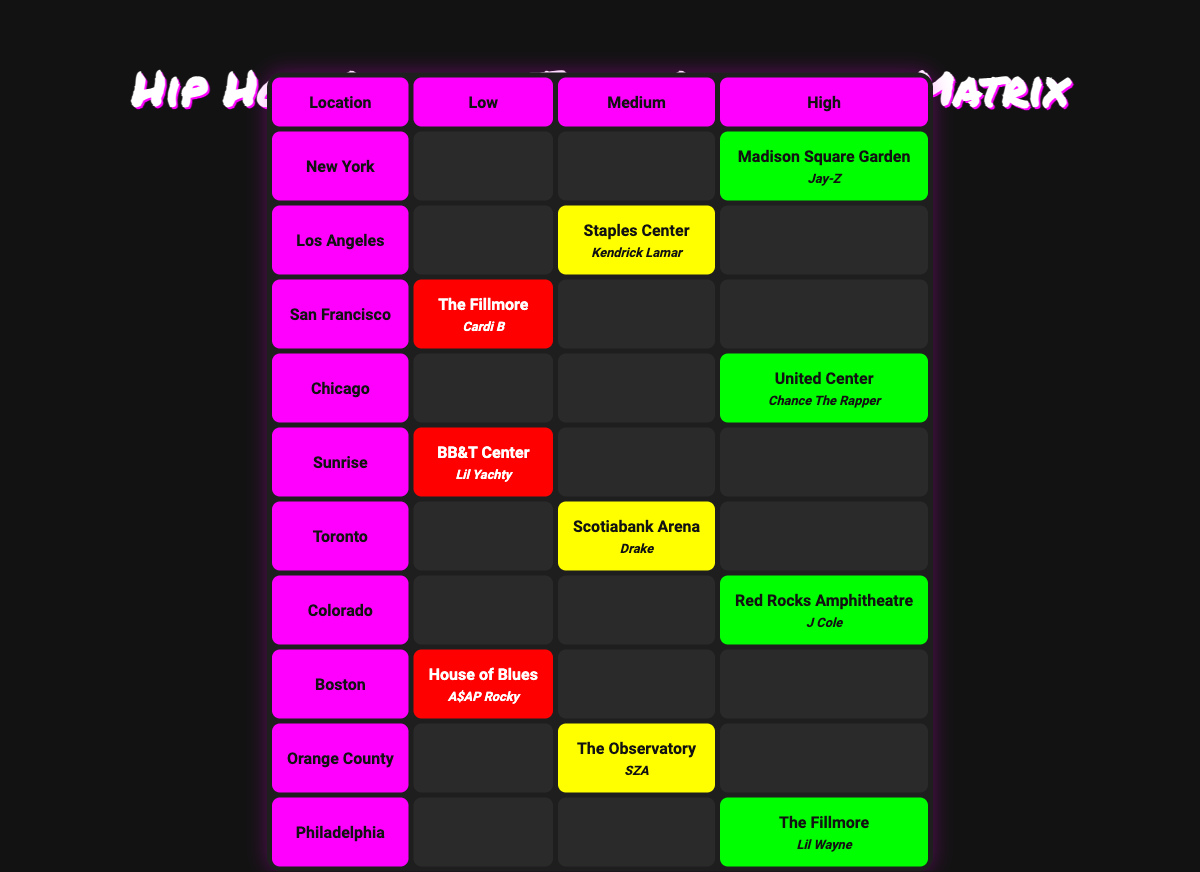What concert location had the highest ticket sales? According to the table, Madison Square Garden in New York shows a high ticket sale, identified in the "High" column. To verify, I check each city and find that "High" ticket sales apply to both Madison Square Garden and the United Center in Chicago, but Madison Square Garden is the first listed.
Answer: Madison Square Garden, New York Did any artist achieve low ticket sales in a major city? The table indicates that The Fillmore in San Francisco had low ticket sales. San Francisco is a major city, hence the answer is verified from the cell's data.
Answer: Yes How many locations had medium ticket sales? The matrix shows three locations with medium ticket sales: Staples Center in Los Angeles, Scotiabank Arena in Toronto, and The Observatory in Orange County. Counting these entries, we find three.
Answer: Three Which artist performed at the location with the lowest ticket sales? The lowest ticket sales were at the House of Blues in Boston, where A$AP Rocky performed. Cross-checking the table confirms A$AP Rocky matches the location in the low sales category.
Answer: A$AP Rocky Are there more locations with high ticket sales than low ticket sales? Evaluating the "High" and "Low" columns, I find four locations had high ticket sales (Madison Square Garden, United Center, Red Rocks Amphitheatre, The Fillmore, Philadelphia) and three had low ticket sales (The Fillmore, San Francisco; BB&T Center, Sunrise; House of Blues, Boston). Since four is more than three, high sales outnumber low.
Answer: Yes What is the difference in the number of medium and low ticket sales locations? From the data, I identified three medium ticket sales locations (Staples Center, Scotiabank Arena, The Observatory) and three low ticket sales locations (The Fillmore, BB&T Center, House of Blues). The difference is calculated as three medium locations minus three low locations, resulting in zero.
Answer: Zero Which city had both a low and a high ticket sales location? By examining the table, the cities of San Francisco (low - The Fillmore) and Chicago (high - United Center) are listed, but only Chicago has a high ticket sale while also showing no low ticket sale. Thus, the only city fitting both criteria appears with only one type of sales.
Answer: None 